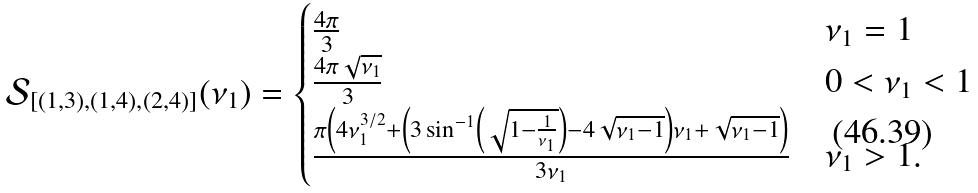Convert formula to latex. <formula><loc_0><loc_0><loc_500><loc_500>\mathcal { S } _ { [ ( 1 , 3 ) , ( 1 , 4 ) , ( 2 , 4 ) ] } ( \nu _ { 1 } ) = \begin{cases} \frac { 4 \pi } { 3 } & \nu _ { 1 } = 1 \\ \frac { 4 \pi \sqrt { \nu _ { 1 } } } { 3 } & 0 < \nu _ { 1 } < 1 \\ \frac { \pi \left ( 4 \nu _ { 1 } ^ { 3 / 2 } + \left ( 3 \sin ^ { - 1 } \left ( \sqrt { 1 - \frac { 1 } { \nu _ { 1 } } } \right ) - 4 \sqrt { \nu _ { 1 } - 1 } \right ) \nu _ { 1 } + \sqrt { \nu _ { 1 } - 1 } \right ) } { 3 \nu _ { 1 } } & \nu _ { 1 } > 1 . \end{cases}</formula> 